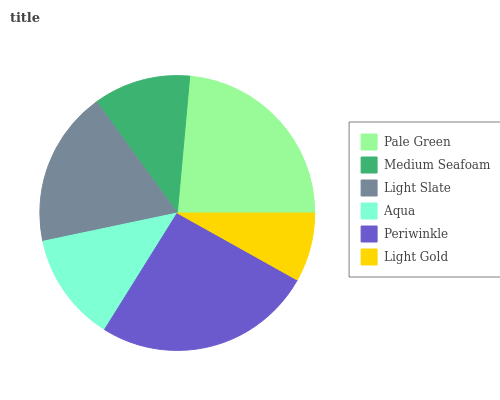Is Light Gold the minimum?
Answer yes or no. Yes. Is Periwinkle the maximum?
Answer yes or no. Yes. Is Medium Seafoam the minimum?
Answer yes or no. No. Is Medium Seafoam the maximum?
Answer yes or no. No. Is Pale Green greater than Medium Seafoam?
Answer yes or no. Yes. Is Medium Seafoam less than Pale Green?
Answer yes or no. Yes. Is Medium Seafoam greater than Pale Green?
Answer yes or no. No. Is Pale Green less than Medium Seafoam?
Answer yes or no. No. Is Light Slate the high median?
Answer yes or no. Yes. Is Aqua the low median?
Answer yes or no. Yes. Is Light Gold the high median?
Answer yes or no. No. Is Pale Green the low median?
Answer yes or no. No. 